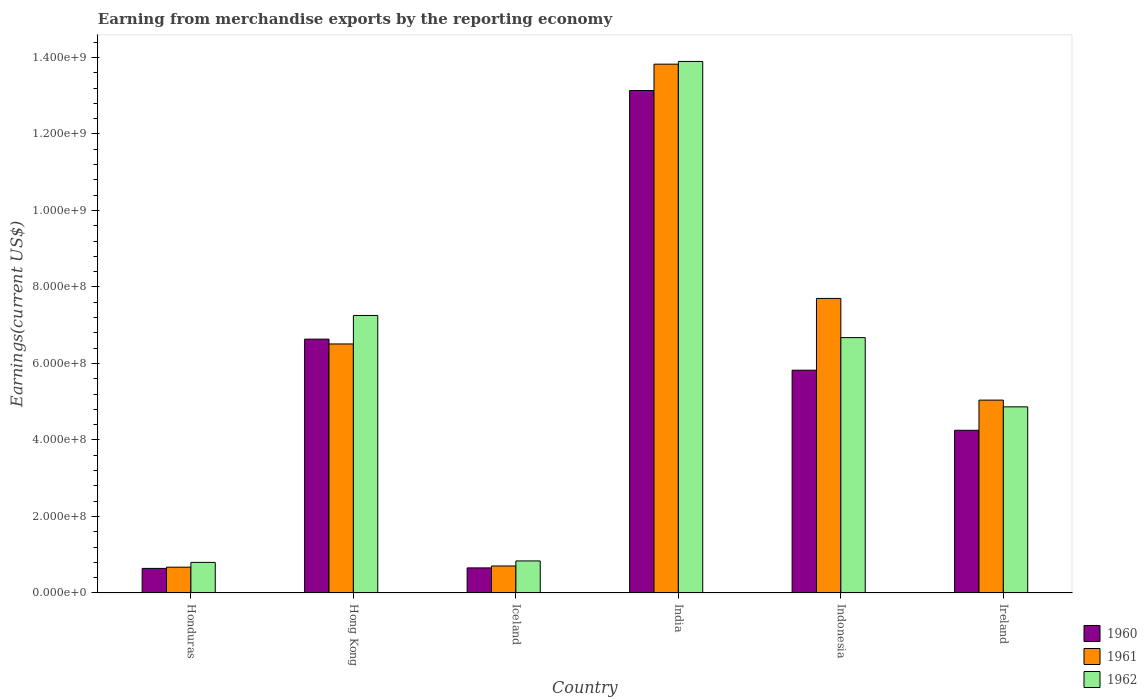How many bars are there on the 2nd tick from the right?
Ensure brevity in your answer.  3. What is the label of the 4th group of bars from the left?
Your answer should be very brief. India. What is the amount earned from merchandise exports in 1962 in India?
Your response must be concise. 1.39e+09. Across all countries, what is the maximum amount earned from merchandise exports in 1962?
Your answer should be compact. 1.39e+09. Across all countries, what is the minimum amount earned from merchandise exports in 1961?
Keep it short and to the point. 6.75e+07. In which country was the amount earned from merchandise exports in 1961 minimum?
Keep it short and to the point. Honduras. What is the total amount earned from merchandise exports in 1961 in the graph?
Your answer should be very brief. 3.45e+09. What is the difference between the amount earned from merchandise exports in 1962 in Honduras and that in Ireland?
Your answer should be compact. -4.07e+08. What is the difference between the amount earned from merchandise exports in 1962 in Honduras and the amount earned from merchandise exports in 1961 in Hong Kong?
Offer a terse response. -5.71e+08. What is the average amount earned from merchandise exports in 1962 per country?
Give a very brief answer. 5.72e+08. What is the difference between the amount earned from merchandise exports of/in 1961 and amount earned from merchandise exports of/in 1960 in Ireland?
Your response must be concise. 7.89e+07. What is the ratio of the amount earned from merchandise exports in 1960 in Hong Kong to that in Iceland?
Provide a succinct answer. 10.12. Is the amount earned from merchandise exports in 1960 in Hong Kong less than that in India?
Provide a succinct answer. Yes. Is the difference between the amount earned from merchandise exports in 1961 in Iceland and Ireland greater than the difference between the amount earned from merchandise exports in 1960 in Iceland and Ireland?
Your answer should be very brief. No. What is the difference between the highest and the second highest amount earned from merchandise exports in 1960?
Keep it short and to the point. 7.31e+08. What is the difference between the highest and the lowest amount earned from merchandise exports in 1961?
Make the answer very short. 1.31e+09. Is the sum of the amount earned from merchandise exports in 1961 in Hong Kong and Indonesia greater than the maximum amount earned from merchandise exports in 1960 across all countries?
Your answer should be compact. Yes. What does the 3rd bar from the left in India represents?
Provide a succinct answer. 1962. What does the 1st bar from the right in India represents?
Provide a short and direct response. 1962. How many bars are there?
Make the answer very short. 18. What is the difference between two consecutive major ticks on the Y-axis?
Your answer should be very brief. 2.00e+08. Where does the legend appear in the graph?
Your response must be concise. Bottom right. How many legend labels are there?
Provide a succinct answer. 3. What is the title of the graph?
Your answer should be very brief. Earning from merchandise exports by the reporting economy. What is the label or title of the X-axis?
Your answer should be compact. Country. What is the label or title of the Y-axis?
Keep it short and to the point. Earnings(current US$). What is the Earnings(current US$) of 1960 in Honduras?
Provide a succinct answer. 6.43e+07. What is the Earnings(current US$) in 1961 in Honduras?
Offer a very short reply. 6.75e+07. What is the Earnings(current US$) in 1962 in Honduras?
Your response must be concise. 8.00e+07. What is the Earnings(current US$) of 1960 in Hong Kong?
Make the answer very short. 6.64e+08. What is the Earnings(current US$) of 1961 in Hong Kong?
Your answer should be compact. 6.51e+08. What is the Earnings(current US$) in 1962 in Hong Kong?
Ensure brevity in your answer.  7.26e+08. What is the Earnings(current US$) in 1960 in Iceland?
Provide a short and direct response. 6.56e+07. What is the Earnings(current US$) in 1961 in Iceland?
Provide a short and direct response. 7.06e+07. What is the Earnings(current US$) of 1962 in Iceland?
Your response must be concise. 8.38e+07. What is the Earnings(current US$) in 1960 in India?
Your answer should be very brief. 1.31e+09. What is the Earnings(current US$) in 1961 in India?
Offer a terse response. 1.38e+09. What is the Earnings(current US$) in 1962 in India?
Give a very brief answer. 1.39e+09. What is the Earnings(current US$) in 1960 in Indonesia?
Keep it short and to the point. 5.82e+08. What is the Earnings(current US$) in 1961 in Indonesia?
Your answer should be compact. 7.70e+08. What is the Earnings(current US$) in 1962 in Indonesia?
Your answer should be very brief. 6.68e+08. What is the Earnings(current US$) of 1960 in Ireland?
Offer a very short reply. 4.25e+08. What is the Earnings(current US$) of 1961 in Ireland?
Your response must be concise. 5.04e+08. What is the Earnings(current US$) in 1962 in Ireland?
Offer a very short reply. 4.87e+08. Across all countries, what is the maximum Earnings(current US$) of 1960?
Your answer should be compact. 1.31e+09. Across all countries, what is the maximum Earnings(current US$) in 1961?
Keep it short and to the point. 1.38e+09. Across all countries, what is the maximum Earnings(current US$) of 1962?
Keep it short and to the point. 1.39e+09. Across all countries, what is the minimum Earnings(current US$) in 1960?
Your answer should be very brief. 6.43e+07. Across all countries, what is the minimum Earnings(current US$) in 1961?
Provide a succinct answer. 6.75e+07. Across all countries, what is the minimum Earnings(current US$) of 1962?
Ensure brevity in your answer.  8.00e+07. What is the total Earnings(current US$) of 1960 in the graph?
Give a very brief answer. 3.11e+09. What is the total Earnings(current US$) of 1961 in the graph?
Give a very brief answer. 3.45e+09. What is the total Earnings(current US$) in 1962 in the graph?
Ensure brevity in your answer.  3.43e+09. What is the difference between the Earnings(current US$) of 1960 in Honduras and that in Hong Kong?
Offer a very short reply. -5.99e+08. What is the difference between the Earnings(current US$) of 1961 in Honduras and that in Hong Kong?
Keep it short and to the point. -5.84e+08. What is the difference between the Earnings(current US$) of 1962 in Honduras and that in Hong Kong?
Your response must be concise. -6.46e+08. What is the difference between the Earnings(current US$) in 1960 in Honduras and that in Iceland?
Ensure brevity in your answer.  -1.30e+06. What is the difference between the Earnings(current US$) in 1961 in Honduras and that in Iceland?
Offer a terse response. -3.10e+06. What is the difference between the Earnings(current US$) in 1962 in Honduras and that in Iceland?
Your answer should be very brief. -3.80e+06. What is the difference between the Earnings(current US$) of 1960 in Honduras and that in India?
Make the answer very short. -1.25e+09. What is the difference between the Earnings(current US$) in 1961 in Honduras and that in India?
Make the answer very short. -1.31e+09. What is the difference between the Earnings(current US$) in 1962 in Honduras and that in India?
Offer a terse response. -1.31e+09. What is the difference between the Earnings(current US$) of 1960 in Honduras and that in Indonesia?
Your answer should be compact. -5.18e+08. What is the difference between the Earnings(current US$) of 1961 in Honduras and that in Indonesia?
Keep it short and to the point. -7.02e+08. What is the difference between the Earnings(current US$) in 1962 in Honduras and that in Indonesia?
Offer a terse response. -5.88e+08. What is the difference between the Earnings(current US$) of 1960 in Honduras and that in Ireland?
Give a very brief answer. -3.61e+08. What is the difference between the Earnings(current US$) in 1961 in Honduras and that in Ireland?
Provide a short and direct response. -4.37e+08. What is the difference between the Earnings(current US$) in 1962 in Honduras and that in Ireland?
Keep it short and to the point. -4.07e+08. What is the difference between the Earnings(current US$) in 1960 in Hong Kong and that in Iceland?
Make the answer very short. 5.98e+08. What is the difference between the Earnings(current US$) of 1961 in Hong Kong and that in Iceland?
Provide a short and direct response. 5.80e+08. What is the difference between the Earnings(current US$) of 1962 in Hong Kong and that in Iceland?
Your response must be concise. 6.42e+08. What is the difference between the Earnings(current US$) of 1960 in Hong Kong and that in India?
Offer a terse response. -6.50e+08. What is the difference between the Earnings(current US$) in 1961 in Hong Kong and that in India?
Make the answer very short. -7.31e+08. What is the difference between the Earnings(current US$) in 1962 in Hong Kong and that in India?
Provide a succinct answer. -6.64e+08. What is the difference between the Earnings(current US$) in 1960 in Hong Kong and that in Indonesia?
Ensure brevity in your answer.  8.12e+07. What is the difference between the Earnings(current US$) in 1961 in Hong Kong and that in Indonesia?
Make the answer very short. -1.19e+08. What is the difference between the Earnings(current US$) of 1962 in Hong Kong and that in Indonesia?
Your answer should be compact. 5.79e+07. What is the difference between the Earnings(current US$) of 1960 in Hong Kong and that in Ireland?
Provide a short and direct response. 2.38e+08. What is the difference between the Earnings(current US$) of 1961 in Hong Kong and that in Ireland?
Provide a short and direct response. 1.47e+08. What is the difference between the Earnings(current US$) of 1962 in Hong Kong and that in Ireland?
Provide a short and direct response. 2.39e+08. What is the difference between the Earnings(current US$) of 1960 in Iceland and that in India?
Give a very brief answer. -1.25e+09. What is the difference between the Earnings(current US$) of 1961 in Iceland and that in India?
Provide a succinct answer. -1.31e+09. What is the difference between the Earnings(current US$) in 1962 in Iceland and that in India?
Give a very brief answer. -1.31e+09. What is the difference between the Earnings(current US$) of 1960 in Iceland and that in Indonesia?
Your response must be concise. -5.17e+08. What is the difference between the Earnings(current US$) of 1961 in Iceland and that in Indonesia?
Keep it short and to the point. -6.99e+08. What is the difference between the Earnings(current US$) in 1962 in Iceland and that in Indonesia?
Provide a short and direct response. -5.84e+08. What is the difference between the Earnings(current US$) of 1960 in Iceland and that in Ireland?
Provide a succinct answer. -3.60e+08. What is the difference between the Earnings(current US$) of 1961 in Iceland and that in Ireland?
Give a very brief answer. -4.34e+08. What is the difference between the Earnings(current US$) of 1962 in Iceland and that in Ireland?
Provide a succinct answer. -4.03e+08. What is the difference between the Earnings(current US$) of 1960 in India and that in Indonesia?
Your response must be concise. 7.31e+08. What is the difference between the Earnings(current US$) of 1961 in India and that in Indonesia?
Your response must be concise. 6.12e+08. What is the difference between the Earnings(current US$) in 1962 in India and that in Indonesia?
Provide a short and direct response. 7.22e+08. What is the difference between the Earnings(current US$) of 1960 in India and that in Ireland?
Give a very brief answer. 8.88e+08. What is the difference between the Earnings(current US$) in 1961 in India and that in Ireland?
Your answer should be compact. 8.78e+08. What is the difference between the Earnings(current US$) of 1962 in India and that in Ireland?
Your response must be concise. 9.03e+08. What is the difference between the Earnings(current US$) of 1960 in Indonesia and that in Ireland?
Keep it short and to the point. 1.57e+08. What is the difference between the Earnings(current US$) of 1961 in Indonesia and that in Ireland?
Offer a terse response. 2.66e+08. What is the difference between the Earnings(current US$) of 1962 in Indonesia and that in Ireland?
Keep it short and to the point. 1.81e+08. What is the difference between the Earnings(current US$) in 1960 in Honduras and the Earnings(current US$) in 1961 in Hong Kong?
Provide a succinct answer. -5.87e+08. What is the difference between the Earnings(current US$) of 1960 in Honduras and the Earnings(current US$) of 1962 in Hong Kong?
Your answer should be very brief. -6.61e+08. What is the difference between the Earnings(current US$) in 1961 in Honduras and the Earnings(current US$) in 1962 in Hong Kong?
Your answer should be very brief. -6.58e+08. What is the difference between the Earnings(current US$) in 1960 in Honduras and the Earnings(current US$) in 1961 in Iceland?
Make the answer very short. -6.30e+06. What is the difference between the Earnings(current US$) in 1960 in Honduras and the Earnings(current US$) in 1962 in Iceland?
Offer a terse response. -1.95e+07. What is the difference between the Earnings(current US$) of 1961 in Honduras and the Earnings(current US$) of 1962 in Iceland?
Your answer should be compact. -1.63e+07. What is the difference between the Earnings(current US$) of 1960 in Honduras and the Earnings(current US$) of 1961 in India?
Offer a terse response. -1.32e+09. What is the difference between the Earnings(current US$) in 1960 in Honduras and the Earnings(current US$) in 1962 in India?
Your answer should be very brief. -1.33e+09. What is the difference between the Earnings(current US$) of 1961 in Honduras and the Earnings(current US$) of 1962 in India?
Offer a terse response. -1.32e+09. What is the difference between the Earnings(current US$) in 1960 in Honduras and the Earnings(current US$) in 1961 in Indonesia?
Offer a very short reply. -7.06e+08. What is the difference between the Earnings(current US$) in 1960 in Honduras and the Earnings(current US$) in 1962 in Indonesia?
Ensure brevity in your answer.  -6.03e+08. What is the difference between the Earnings(current US$) in 1961 in Honduras and the Earnings(current US$) in 1962 in Indonesia?
Give a very brief answer. -6.00e+08. What is the difference between the Earnings(current US$) of 1960 in Honduras and the Earnings(current US$) of 1961 in Ireland?
Provide a succinct answer. -4.40e+08. What is the difference between the Earnings(current US$) of 1960 in Honduras and the Earnings(current US$) of 1962 in Ireland?
Your response must be concise. -4.22e+08. What is the difference between the Earnings(current US$) in 1961 in Honduras and the Earnings(current US$) in 1962 in Ireland?
Offer a terse response. -4.19e+08. What is the difference between the Earnings(current US$) in 1960 in Hong Kong and the Earnings(current US$) in 1961 in Iceland?
Your answer should be very brief. 5.93e+08. What is the difference between the Earnings(current US$) in 1960 in Hong Kong and the Earnings(current US$) in 1962 in Iceland?
Provide a succinct answer. 5.80e+08. What is the difference between the Earnings(current US$) in 1961 in Hong Kong and the Earnings(current US$) in 1962 in Iceland?
Offer a very short reply. 5.67e+08. What is the difference between the Earnings(current US$) of 1960 in Hong Kong and the Earnings(current US$) of 1961 in India?
Make the answer very short. -7.19e+08. What is the difference between the Earnings(current US$) of 1960 in Hong Kong and the Earnings(current US$) of 1962 in India?
Your answer should be very brief. -7.26e+08. What is the difference between the Earnings(current US$) of 1961 in Hong Kong and the Earnings(current US$) of 1962 in India?
Ensure brevity in your answer.  -7.38e+08. What is the difference between the Earnings(current US$) of 1960 in Hong Kong and the Earnings(current US$) of 1961 in Indonesia?
Offer a very short reply. -1.06e+08. What is the difference between the Earnings(current US$) of 1960 in Hong Kong and the Earnings(current US$) of 1962 in Indonesia?
Offer a terse response. -4.00e+06. What is the difference between the Earnings(current US$) in 1961 in Hong Kong and the Earnings(current US$) in 1962 in Indonesia?
Keep it short and to the point. -1.66e+07. What is the difference between the Earnings(current US$) of 1960 in Hong Kong and the Earnings(current US$) of 1961 in Ireland?
Keep it short and to the point. 1.59e+08. What is the difference between the Earnings(current US$) of 1960 in Hong Kong and the Earnings(current US$) of 1962 in Ireland?
Your answer should be compact. 1.77e+08. What is the difference between the Earnings(current US$) of 1961 in Hong Kong and the Earnings(current US$) of 1962 in Ireland?
Ensure brevity in your answer.  1.64e+08. What is the difference between the Earnings(current US$) of 1960 in Iceland and the Earnings(current US$) of 1961 in India?
Provide a short and direct response. -1.32e+09. What is the difference between the Earnings(current US$) of 1960 in Iceland and the Earnings(current US$) of 1962 in India?
Your answer should be very brief. -1.32e+09. What is the difference between the Earnings(current US$) in 1961 in Iceland and the Earnings(current US$) in 1962 in India?
Ensure brevity in your answer.  -1.32e+09. What is the difference between the Earnings(current US$) of 1960 in Iceland and the Earnings(current US$) of 1961 in Indonesia?
Give a very brief answer. -7.04e+08. What is the difference between the Earnings(current US$) in 1960 in Iceland and the Earnings(current US$) in 1962 in Indonesia?
Offer a terse response. -6.02e+08. What is the difference between the Earnings(current US$) in 1961 in Iceland and the Earnings(current US$) in 1962 in Indonesia?
Make the answer very short. -5.97e+08. What is the difference between the Earnings(current US$) in 1960 in Iceland and the Earnings(current US$) in 1961 in Ireland?
Provide a succinct answer. -4.39e+08. What is the difference between the Earnings(current US$) in 1960 in Iceland and the Earnings(current US$) in 1962 in Ireland?
Provide a succinct answer. -4.21e+08. What is the difference between the Earnings(current US$) in 1961 in Iceland and the Earnings(current US$) in 1962 in Ireland?
Your answer should be compact. -4.16e+08. What is the difference between the Earnings(current US$) of 1960 in India and the Earnings(current US$) of 1961 in Indonesia?
Ensure brevity in your answer.  5.44e+08. What is the difference between the Earnings(current US$) of 1960 in India and the Earnings(current US$) of 1962 in Indonesia?
Provide a succinct answer. 6.46e+08. What is the difference between the Earnings(current US$) of 1961 in India and the Earnings(current US$) of 1962 in Indonesia?
Your answer should be very brief. 7.15e+08. What is the difference between the Earnings(current US$) of 1960 in India and the Earnings(current US$) of 1961 in Ireland?
Your answer should be compact. 8.09e+08. What is the difference between the Earnings(current US$) in 1960 in India and the Earnings(current US$) in 1962 in Ireland?
Offer a terse response. 8.27e+08. What is the difference between the Earnings(current US$) of 1961 in India and the Earnings(current US$) of 1962 in Ireland?
Provide a short and direct response. 8.96e+08. What is the difference between the Earnings(current US$) in 1960 in Indonesia and the Earnings(current US$) in 1961 in Ireland?
Ensure brevity in your answer.  7.82e+07. What is the difference between the Earnings(current US$) of 1960 in Indonesia and the Earnings(current US$) of 1962 in Ireland?
Offer a terse response. 9.58e+07. What is the difference between the Earnings(current US$) of 1961 in Indonesia and the Earnings(current US$) of 1962 in Ireland?
Your answer should be very brief. 2.83e+08. What is the average Earnings(current US$) of 1960 per country?
Offer a very short reply. 5.19e+08. What is the average Earnings(current US$) of 1961 per country?
Offer a terse response. 5.74e+08. What is the average Earnings(current US$) in 1962 per country?
Provide a short and direct response. 5.72e+08. What is the difference between the Earnings(current US$) in 1960 and Earnings(current US$) in 1961 in Honduras?
Provide a short and direct response. -3.20e+06. What is the difference between the Earnings(current US$) of 1960 and Earnings(current US$) of 1962 in Honduras?
Ensure brevity in your answer.  -1.57e+07. What is the difference between the Earnings(current US$) in 1961 and Earnings(current US$) in 1962 in Honduras?
Ensure brevity in your answer.  -1.25e+07. What is the difference between the Earnings(current US$) of 1960 and Earnings(current US$) of 1961 in Hong Kong?
Your response must be concise. 1.26e+07. What is the difference between the Earnings(current US$) in 1960 and Earnings(current US$) in 1962 in Hong Kong?
Your answer should be compact. -6.19e+07. What is the difference between the Earnings(current US$) of 1961 and Earnings(current US$) of 1962 in Hong Kong?
Give a very brief answer. -7.45e+07. What is the difference between the Earnings(current US$) of 1960 and Earnings(current US$) of 1961 in Iceland?
Ensure brevity in your answer.  -5.00e+06. What is the difference between the Earnings(current US$) of 1960 and Earnings(current US$) of 1962 in Iceland?
Your answer should be very brief. -1.82e+07. What is the difference between the Earnings(current US$) in 1961 and Earnings(current US$) in 1962 in Iceland?
Ensure brevity in your answer.  -1.32e+07. What is the difference between the Earnings(current US$) in 1960 and Earnings(current US$) in 1961 in India?
Keep it short and to the point. -6.89e+07. What is the difference between the Earnings(current US$) of 1960 and Earnings(current US$) of 1962 in India?
Your answer should be compact. -7.60e+07. What is the difference between the Earnings(current US$) of 1961 and Earnings(current US$) of 1962 in India?
Give a very brief answer. -7.10e+06. What is the difference between the Earnings(current US$) of 1960 and Earnings(current US$) of 1961 in Indonesia?
Your answer should be very brief. -1.88e+08. What is the difference between the Earnings(current US$) in 1960 and Earnings(current US$) in 1962 in Indonesia?
Give a very brief answer. -8.52e+07. What is the difference between the Earnings(current US$) of 1961 and Earnings(current US$) of 1962 in Indonesia?
Your response must be concise. 1.02e+08. What is the difference between the Earnings(current US$) in 1960 and Earnings(current US$) in 1961 in Ireland?
Make the answer very short. -7.89e+07. What is the difference between the Earnings(current US$) of 1960 and Earnings(current US$) of 1962 in Ireland?
Your response must be concise. -6.13e+07. What is the difference between the Earnings(current US$) of 1961 and Earnings(current US$) of 1962 in Ireland?
Offer a very short reply. 1.76e+07. What is the ratio of the Earnings(current US$) of 1960 in Honduras to that in Hong Kong?
Make the answer very short. 0.1. What is the ratio of the Earnings(current US$) of 1961 in Honduras to that in Hong Kong?
Provide a succinct answer. 0.1. What is the ratio of the Earnings(current US$) in 1962 in Honduras to that in Hong Kong?
Make the answer very short. 0.11. What is the ratio of the Earnings(current US$) of 1960 in Honduras to that in Iceland?
Ensure brevity in your answer.  0.98. What is the ratio of the Earnings(current US$) in 1961 in Honduras to that in Iceland?
Provide a short and direct response. 0.96. What is the ratio of the Earnings(current US$) in 1962 in Honduras to that in Iceland?
Your answer should be compact. 0.95. What is the ratio of the Earnings(current US$) of 1960 in Honduras to that in India?
Make the answer very short. 0.05. What is the ratio of the Earnings(current US$) in 1961 in Honduras to that in India?
Offer a terse response. 0.05. What is the ratio of the Earnings(current US$) of 1962 in Honduras to that in India?
Offer a very short reply. 0.06. What is the ratio of the Earnings(current US$) in 1960 in Honduras to that in Indonesia?
Your answer should be very brief. 0.11. What is the ratio of the Earnings(current US$) in 1961 in Honduras to that in Indonesia?
Make the answer very short. 0.09. What is the ratio of the Earnings(current US$) in 1962 in Honduras to that in Indonesia?
Provide a short and direct response. 0.12. What is the ratio of the Earnings(current US$) in 1960 in Honduras to that in Ireland?
Offer a terse response. 0.15. What is the ratio of the Earnings(current US$) in 1961 in Honduras to that in Ireland?
Make the answer very short. 0.13. What is the ratio of the Earnings(current US$) in 1962 in Honduras to that in Ireland?
Offer a terse response. 0.16. What is the ratio of the Earnings(current US$) in 1960 in Hong Kong to that in Iceland?
Provide a succinct answer. 10.12. What is the ratio of the Earnings(current US$) of 1961 in Hong Kong to that in Iceland?
Ensure brevity in your answer.  9.22. What is the ratio of the Earnings(current US$) in 1962 in Hong Kong to that in Iceland?
Give a very brief answer. 8.66. What is the ratio of the Earnings(current US$) of 1960 in Hong Kong to that in India?
Your answer should be compact. 0.51. What is the ratio of the Earnings(current US$) of 1961 in Hong Kong to that in India?
Your response must be concise. 0.47. What is the ratio of the Earnings(current US$) of 1962 in Hong Kong to that in India?
Give a very brief answer. 0.52. What is the ratio of the Earnings(current US$) in 1960 in Hong Kong to that in Indonesia?
Offer a very short reply. 1.14. What is the ratio of the Earnings(current US$) in 1961 in Hong Kong to that in Indonesia?
Keep it short and to the point. 0.85. What is the ratio of the Earnings(current US$) of 1962 in Hong Kong to that in Indonesia?
Offer a very short reply. 1.09. What is the ratio of the Earnings(current US$) in 1960 in Hong Kong to that in Ireland?
Offer a terse response. 1.56. What is the ratio of the Earnings(current US$) in 1961 in Hong Kong to that in Ireland?
Provide a short and direct response. 1.29. What is the ratio of the Earnings(current US$) in 1962 in Hong Kong to that in Ireland?
Ensure brevity in your answer.  1.49. What is the ratio of the Earnings(current US$) of 1960 in Iceland to that in India?
Keep it short and to the point. 0.05. What is the ratio of the Earnings(current US$) in 1961 in Iceland to that in India?
Provide a short and direct response. 0.05. What is the ratio of the Earnings(current US$) in 1962 in Iceland to that in India?
Ensure brevity in your answer.  0.06. What is the ratio of the Earnings(current US$) of 1960 in Iceland to that in Indonesia?
Your response must be concise. 0.11. What is the ratio of the Earnings(current US$) in 1961 in Iceland to that in Indonesia?
Ensure brevity in your answer.  0.09. What is the ratio of the Earnings(current US$) of 1962 in Iceland to that in Indonesia?
Offer a terse response. 0.13. What is the ratio of the Earnings(current US$) in 1960 in Iceland to that in Ireland?
Offer a terse response. 0.15. What is the ratio of the Earnings(current US$) in 1961 in Iceland to that in Ireland?
Your answer should be very brief. 0.14. What is the ratio of the Earnings(current US$) in 1962 in Iceland to that in Ireland?
Make the answer very short. 0.17. What is the ratio of the Earnings(current US$) in 1960 in India to that in Indonesia?
Keep it short and to the point. 2.26. What is the ratio of the Earnings(current US$) of 1961 in India to that in Indonesia?
Give a very brief answer. 1.8. What is the ratio of the Earnings(current US$) of 1962 in India to that in Indonesia?
Give a very brief answer. 2.08. What is the ratio of the Earnings(current US$) in 1960 in India to that in Ireland?
Keep it short and to the point. 3.09. What is the ratio of the Earnings(current US$) in 1961 in India to that in Ireland?
Keep it short and to the point. 2.74. What is the ratio of the Earnings(current US$) of 1962 in India to that in Ireland?
Provide a short and direct response. 2.86. What is the ratio of the Earnings(current US$) of 1960 in Indonesia to that in Ireland?
Ensure brevity in your answer.  1.37. What is the ratio of the Earnings(current US$) in 1961 in Indonesia to that in Ireland?
Ensure brevity in your answer.  1.53. What is the ratio of the Earnings(current US$) of 1962 in Indonesia to that in Ireland?
Provide a succinct answer. 1.37. What is the difference between the highest and the second highest Earnings(current US$) of 1960?
Make the answer very short. 6.50e+08. What is the difference between the highest and the second highest Earnings(current US$) in 1961?
Provide a short and direct response. 6.12e+08. What is the difference between the highest and the second highest Earnings(current US$) of 1962?
Offer a very short reply. 6.64e+08. What is the difference between the highest and the lowest Earnings(current US$) in 1960?
Your answer should be compact. 1.25e+09. What is the difference between the highest and the lowest Earnings(current US$) in 1961?
Your answer should be compact. 1.31e+09. What is the difference between the highest and the lowest Earnings(current US$) in 1962?
Your answer should be very brief. 1.31e+09. 